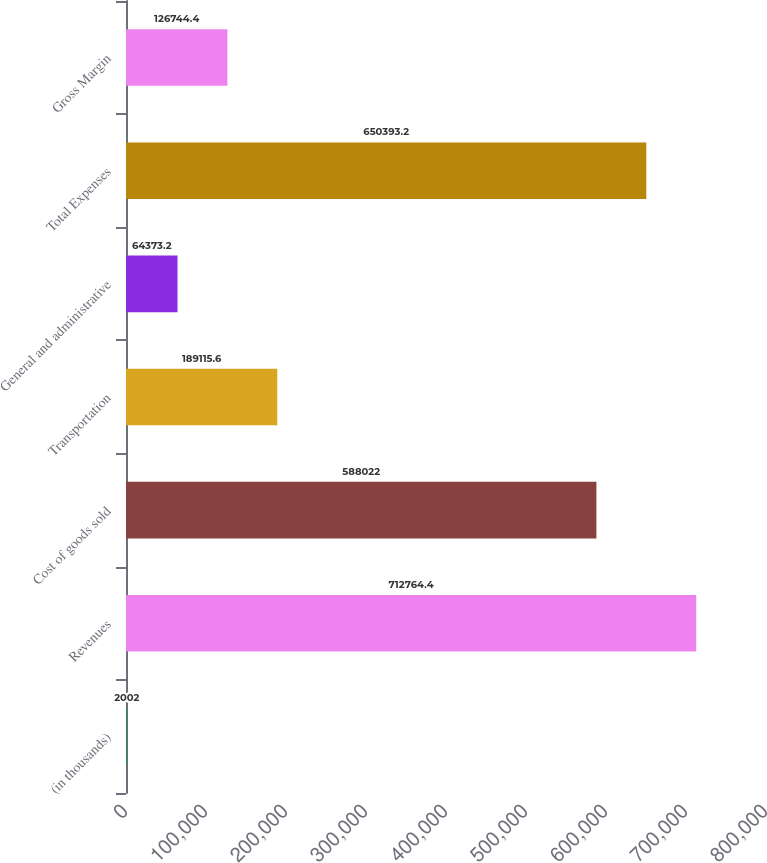Convert chart. <chart><loc_0><loc_0><loc_500><loc_500><bar_chart><fcel>(in thousands)<fcel>Revenues<fcel>Cost of goods sold<fcel>Transportation<fcel>General and administrative<fcel>Total Expenses<fcel>Gross Margin<nl><fcel>2002<fcel>712764<fcel>588022<fcel>189116<fcel>64373.2<fcel>650393<fcel>126744<nl></chart> 